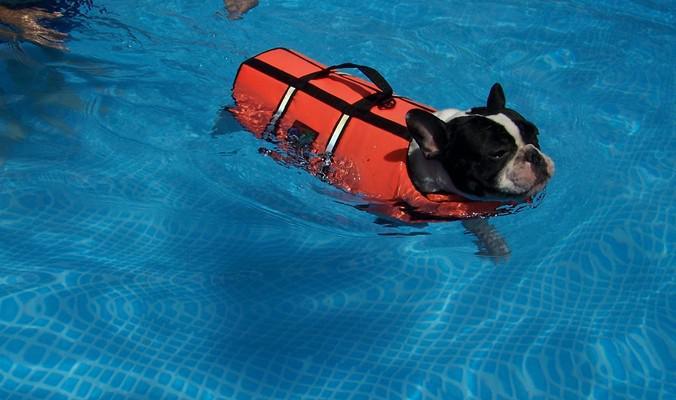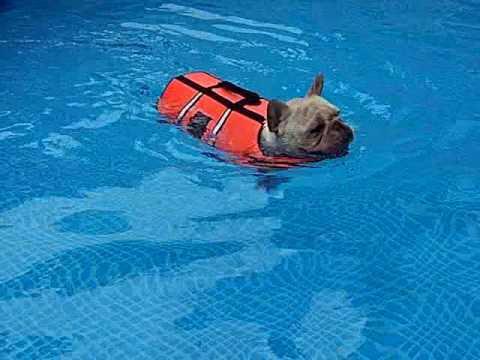The first image is the image on the left, the second image is the image on the right. For the images shown, is this caption "there are dogs floating in the pool on inflatable intertubes" true? Answer yes or no. No. 